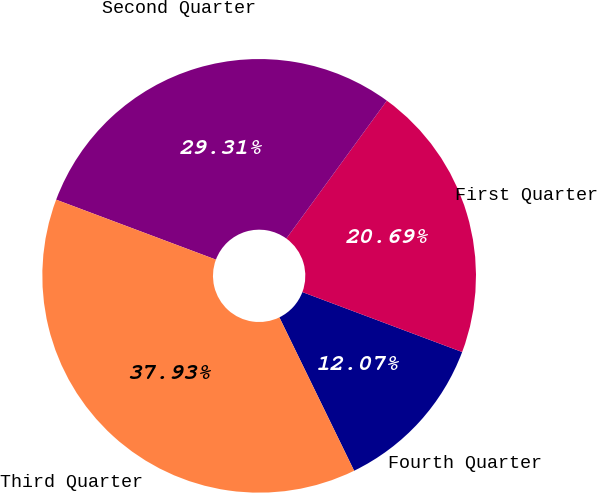Convert chart to OTSL. <chart><loc_0><loc_0><loc_500><loc_500><pie_chart><fcel>Fourth Quarter<fcel>First Quarter<fcel>Second Quarter<fcel>Third Quarter<nl><fcel>12.07%<fcel>20.69%<fcel>29.31%<fcel>37.93%<nl></chart> 